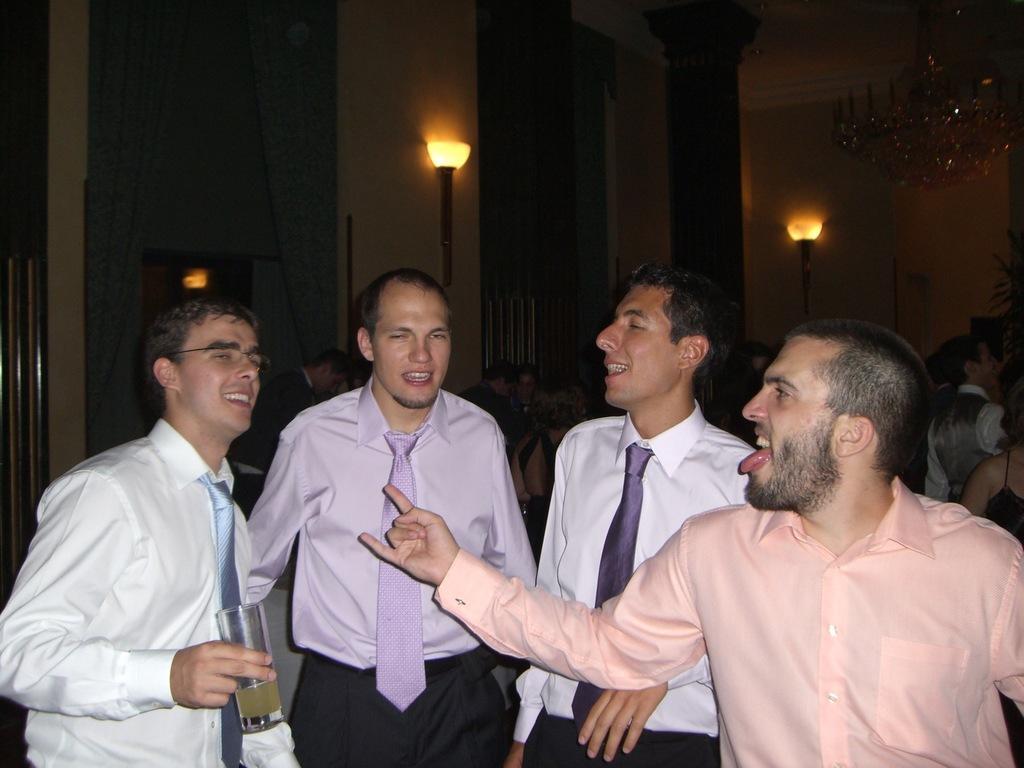In one or two sentences, can you explain what this image depicts? Here I can see four men standing and smiling. It seems like they are dancing. The man who is on the left side is holding a glass in the hand. In the background, I can see some more people. There are few lights and a wall in the dark and also there is a pillar. In the top right-hand corner there is a chandelier. 